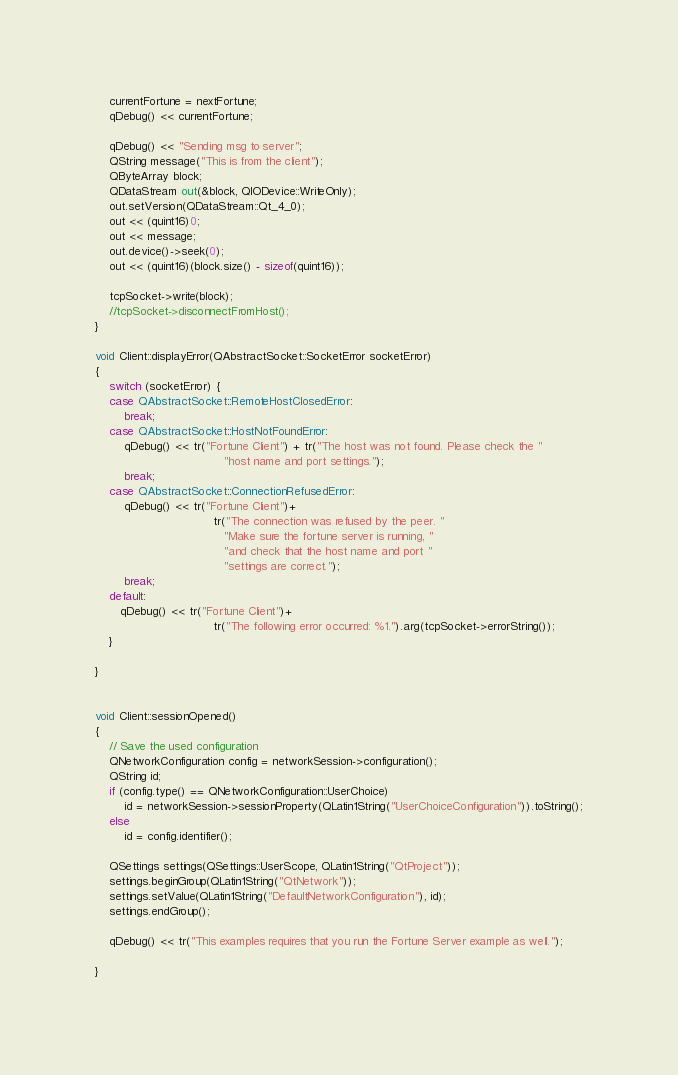Convert code to text. <code><loc_0><loc_0><loc_500><loc_500><_C++_>    currentFortune = nextFortune;
    qDebug() << currentFortune;

    qDebug() << "Sending msg to server";
    QString message("This is from the client");
    QByteArray block;
    QDataStream out(&block, QIODevice::WriteOnly);
    out.setVersion(QDataStream::Qt_4_0);
    out << (quint16)0;
    out << message;
    out.device()->seek(0);
    out << (quint16)(block.size() - sizeof(quint16));

    tcpSocket->write(block);
    //tcpSocket->disconnectFromHost();
}

void Client::displayError(QAbstractSocket::SocketError socketError)
{
    switch (socketError) {
    case QAbstractSocket::RemoteHostClosedError:
        break;
    case QAbstractSocket::HostNotFoundError:
        qDebug() << tr("Fortune Client") + tr("The host was not found. Please check the "
                                    "host name and port settings.");
        break;
    case QAbstractSocket::ConnectionRefusedError:
        qDebug() << tr("Fortune Client")+
                                 tr("The connection was refused by the peer. "
                                    "Make sure the fortune server is running, "
                                    "and check that the host name and port "
                                    "settings are correct.");
        break;
    default:
       qDebug() << tr("Fortune Client")+
                                 tr("The following error occurred: %1.").arg(tcpSocket->errorString());
    }

}


void Client::sessionOpened()
{
    // Save the used configuration
    QNetworkConfiguration config = networkSession->configuration();
    QString id;
    if (config.type() == QNetworkConfiguration::UserChoice)
        id = networkSession->sessionProperty(QLatin1String("UserChoiceConfiguration")).toString();
    else
        id = config.identifier();

    QSettings settings(QSettings::UserScope, QLatin1String("QtProject"));
    settings.beginGroup(QLatin1String("QtNetwork"));
    settings.setValue(QLatin1String("DefaultNetworkConfiguration"), id);
    settings.endGroup();

    qDebug() << tr("This examples requires that you run the Fortune Server example as well.");

}
</code> 